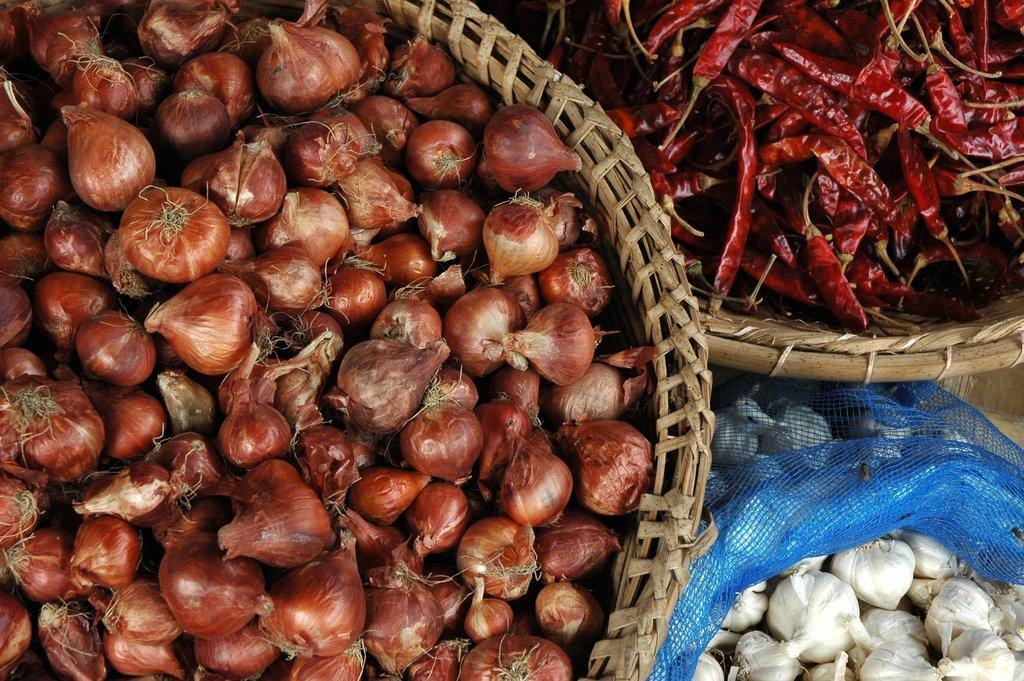What is in the first basket in the image? There is a basket full of onions in the image. What is in the second basket in the image? There is a basket full of red chilies in the image. What is in the blue color bag in the image? There is a blue color bag with ginger in the image. What type of vest is being worn by the onions in the image? There are no onions or any other living beings wearing a vest in the image. Can you see any caves in the image? There are no caves present in the image; it features baskets and a bag with vegetables. 